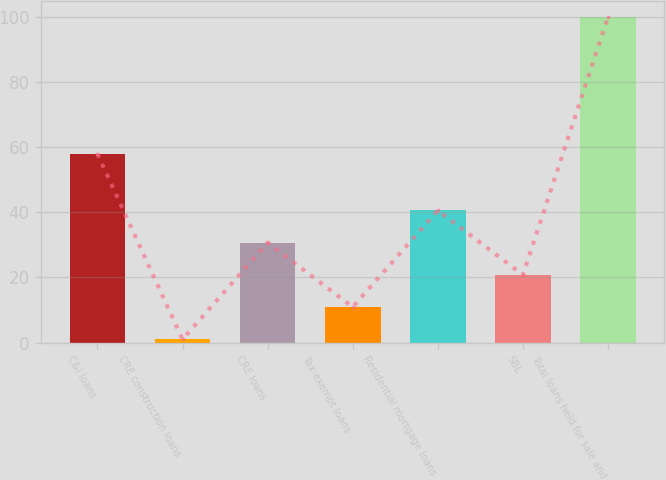<chart> <loc_0><loc_0><loc_500><loc_500><bar_chart><fcel>C&I loans<fcel>CRE construction loans<fcel>CRE loans<fcel>Tax-exempt loans<fcel>Residential mortgage loans<fcel>SBL<fcel>Total loans held for sale and<nl><fcel>58<fcel>1<fcel>30.7<fcel>10.9<fcel>40.6<fcel>20.8<fcel>100<nl></chart> 